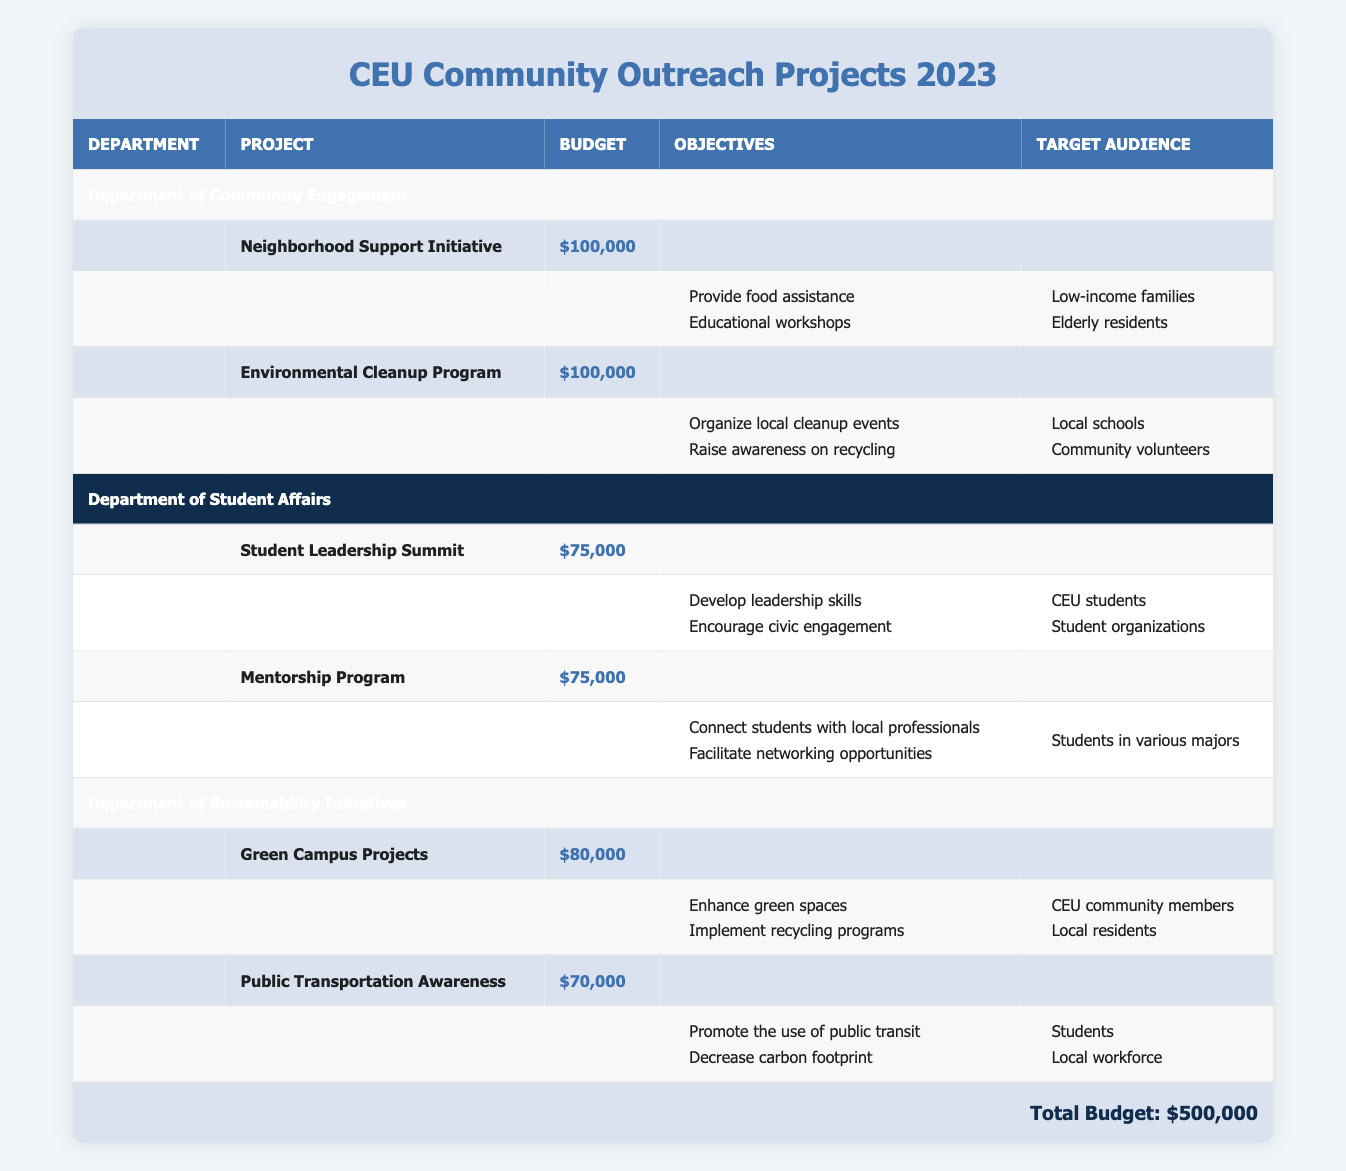What is the total budget allocated for CEU community outreach projects in 2023? The total budget is explicitly stated at the bottom of the table, which shows a total of $500,000.
Answer: 500000 How much budget does the Department of Community Engagement receive? The budget allocation for the Department of Community Engagement is mentioned directly in the table as $200,000.
Answer: 200000 Which project has the largest budget within the Department of Student Affairs? In the Department of Student Affairs, both the Student Leadership Summit and the Mentorship Program have the same budget of $75,000. Thus, they are equally the largest projects according to the table.
Answer: Student Leadership Summit and Mentorship Program Is the total budget allocated to the Department of Sustainability Initiatives greater than that of the Department of Community Engagement? The Department of Sustainability Initiatives has a budget allocation of $150,000, while the Department of Community Engagement has $200,000, so the budget for Sustainability Initiatives is less.
Answer: No What percentage of the total budget is allocated to the Neighborhood Support Initiative? The Neighborhood Support Initiative has a budget of $100,000. To find the percentage, divide $100,000 by the total budget of $500,000 and multiply by 100, resulting in 20%.
Answer: 20% How many projects are funded by the Department of Sustainability Initiatives? The Department of Sustainability Initiatives funds two projects: the Green Campus Projects and the Public Transportation Awareness. This can be directly counted from the table.
Answer: 2 If we combine the budgets of all projects in the Department of Student Affairs, what is the total allocated budget? The total allocated budget for the Department of Student Affairs is calculated by summing the budgets of both projects: $75,000 (Student Leadership Summit) + $75,000 (Mentorship Program) = $150,000.
Answer: 150000 Does the Public Transportation Awareness project target local residents? The Public Transportation Awareness project targets students and the local workforce, as indicated in the table, which means it does not specifically target local residents.
Answer: No What are the objectives of the Environmental Cleanup Program? The objectives of the Environmental Cleanup Program, according to the table, are to organize local cleanup events and raise awareness on recycling. This information is explicitly listed under the project details.
Answer: Organize local cleanup events and raise awareness on recycling 